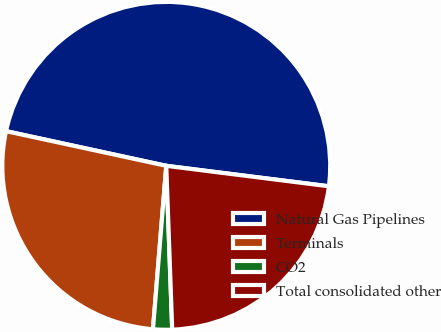Convert chart to OTSL. <chart><loc_0><loc_0><loc_500><loc_500><pie_chart><fcel>Natural Gas Pipelines<fcel>Terminals<fcel>CO2<fcel>Total consolidated other<nl><fcel>48.6%<fcel>27.1%<fcel>1.87%<fcel>22.43%<nl></chart> 